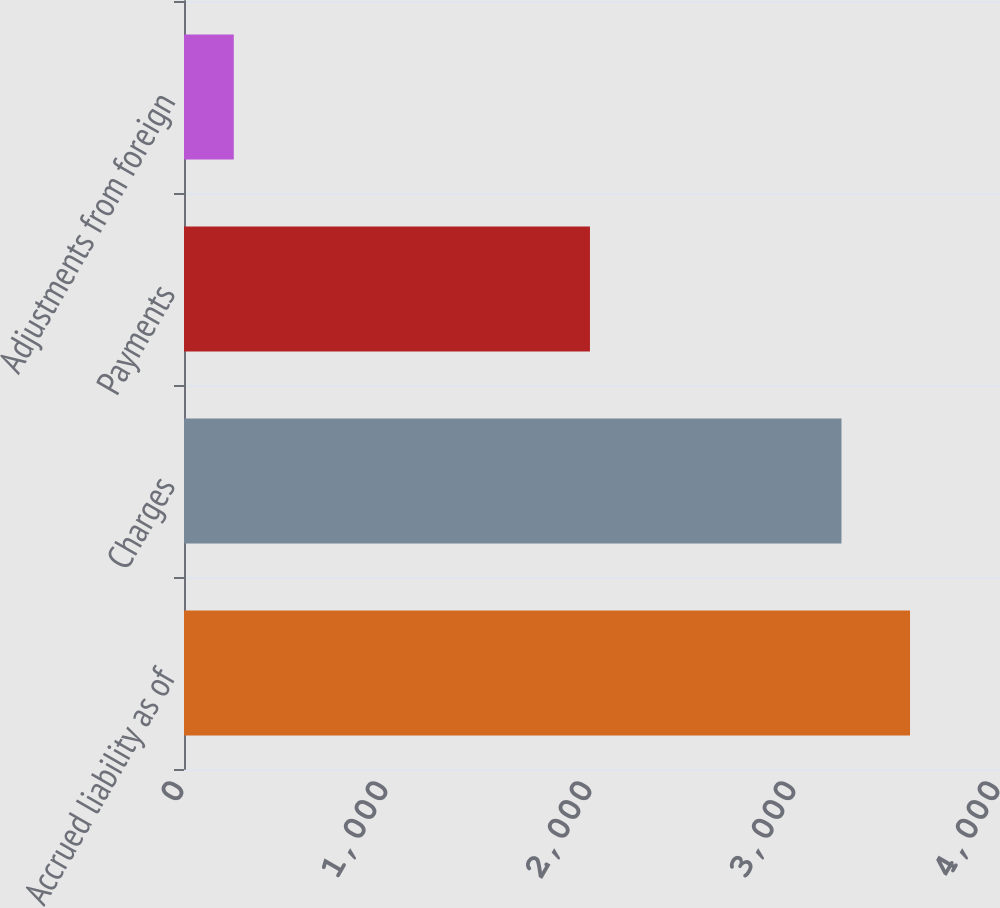Convert chart to OTSL. <chart><loc_0><loc_0><loc_500><loc_500><bar_chart><fcel>Accrued liability as of<fcel>Charges<fcel>Payments<fcel>Adjustments from foreign<nl><fcel>3559<fcel>3223<fcel>1990<fcel>244<nl></chart> 